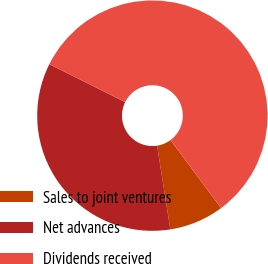Convert chart. <chart><loc_0><loc_0><loc_500><loc_500><pie_chart><fcel>Sales to joint ventures<fcel>Net advances<fcel>Dividends received<nl><fcel>7.68%<fcel>34.86%<fcel>57.46%<nl></chart> 